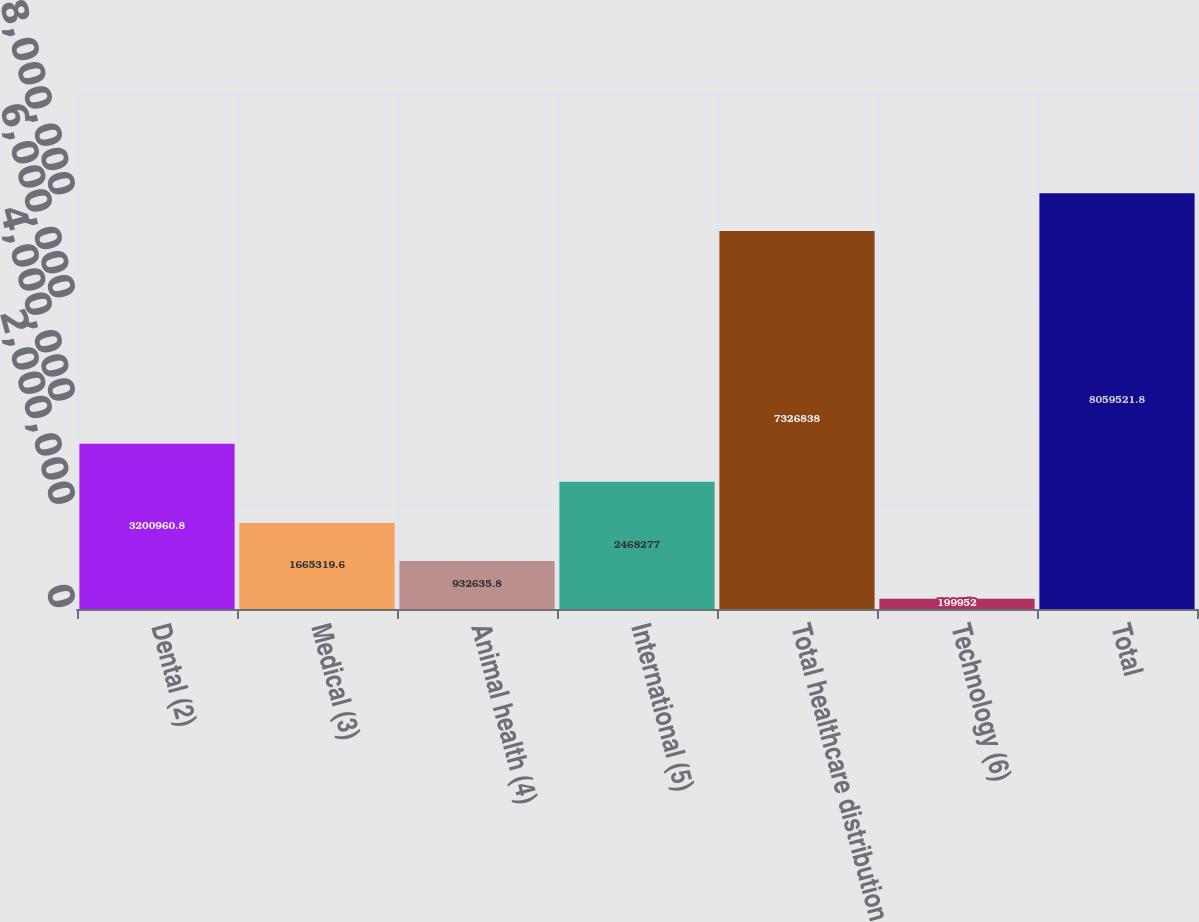Convert chart. <chart><loc_0><loc_0><loc_500><loc_500><bar_chart><fcel>Dental (2)<fcel>Medical (3)<fcel>Animal health (4)<fcel>International (5)<fcel>Total healthcare distribution<fcel>Technology (6)<fcel>Total<nl><fcel>3.20096e+06<fcel>1.66532e+06<fcel>932636<fcel>2.46828e+06<fcel>7.32684e+06<fcel>199952<fcel>8.05952e+06<nl></chart> 